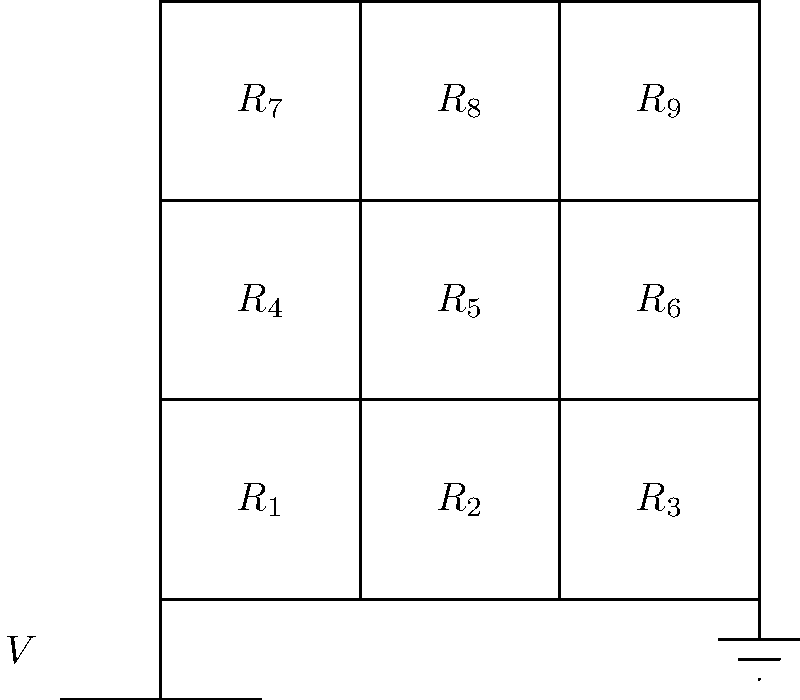In simulating ancient geological formations, you've modeled a section of stratified rock layers as a 3x3 resistor network. Each resistor represents a different rock type with varying conductivity. If all resistors have the same resistance R, what is the equivalent resistance between the top-left and bottom-right corners of the network? To solve this problem, we'll use the concept of symmetry and the properties of series and parallel resistors. Let's approach this step-by-step:

1) First, note that due to the symmetry of the network, the current will flow diagonally from the top-left to the bottom-right corner.

2) We can identify three parallel paths for the current to flow:
   Path 1: $R_1 \rightarrow R_5 \rightarrow R_9$
   Path 2: $R_2 \rightarrow R_5 \rightarrow R_8$ and $R_4 \rightarrow R_5 \rightarrow R_6$
   Path 3: $R_7 \rightarrow R_5 \rightarrow R_3$

3) For Path 1 and Path 3, the resistance is simply:
   $R_{1,3} = 3R$

4) For Path 2, we have two identical paths in parallel. The resistance of each is $3R$, so the combined resistance is:
   $R_2 = \frac{1}{\frac{1}{3R} + \frac{1}{3R}} = \frac{3R}{2}$

5) Now we have three resistances in parallel: $3R$, $\frac{3R}{2}$, and $3R$. The equivalent resistance is:

   $R_{eq} = \frac{1}{\frac{1}{3R} + \frac{2}{3R} + \frac{1}{3R}} = \frac{1}{\frac{4}{3R}} = \frac{3R}{4}$

Therefore, the equivalent resistance between the top-left and bottom-right corners of the network is $\frac{3R}{4}$.
Answer: $\frac{3R}{4}$ 